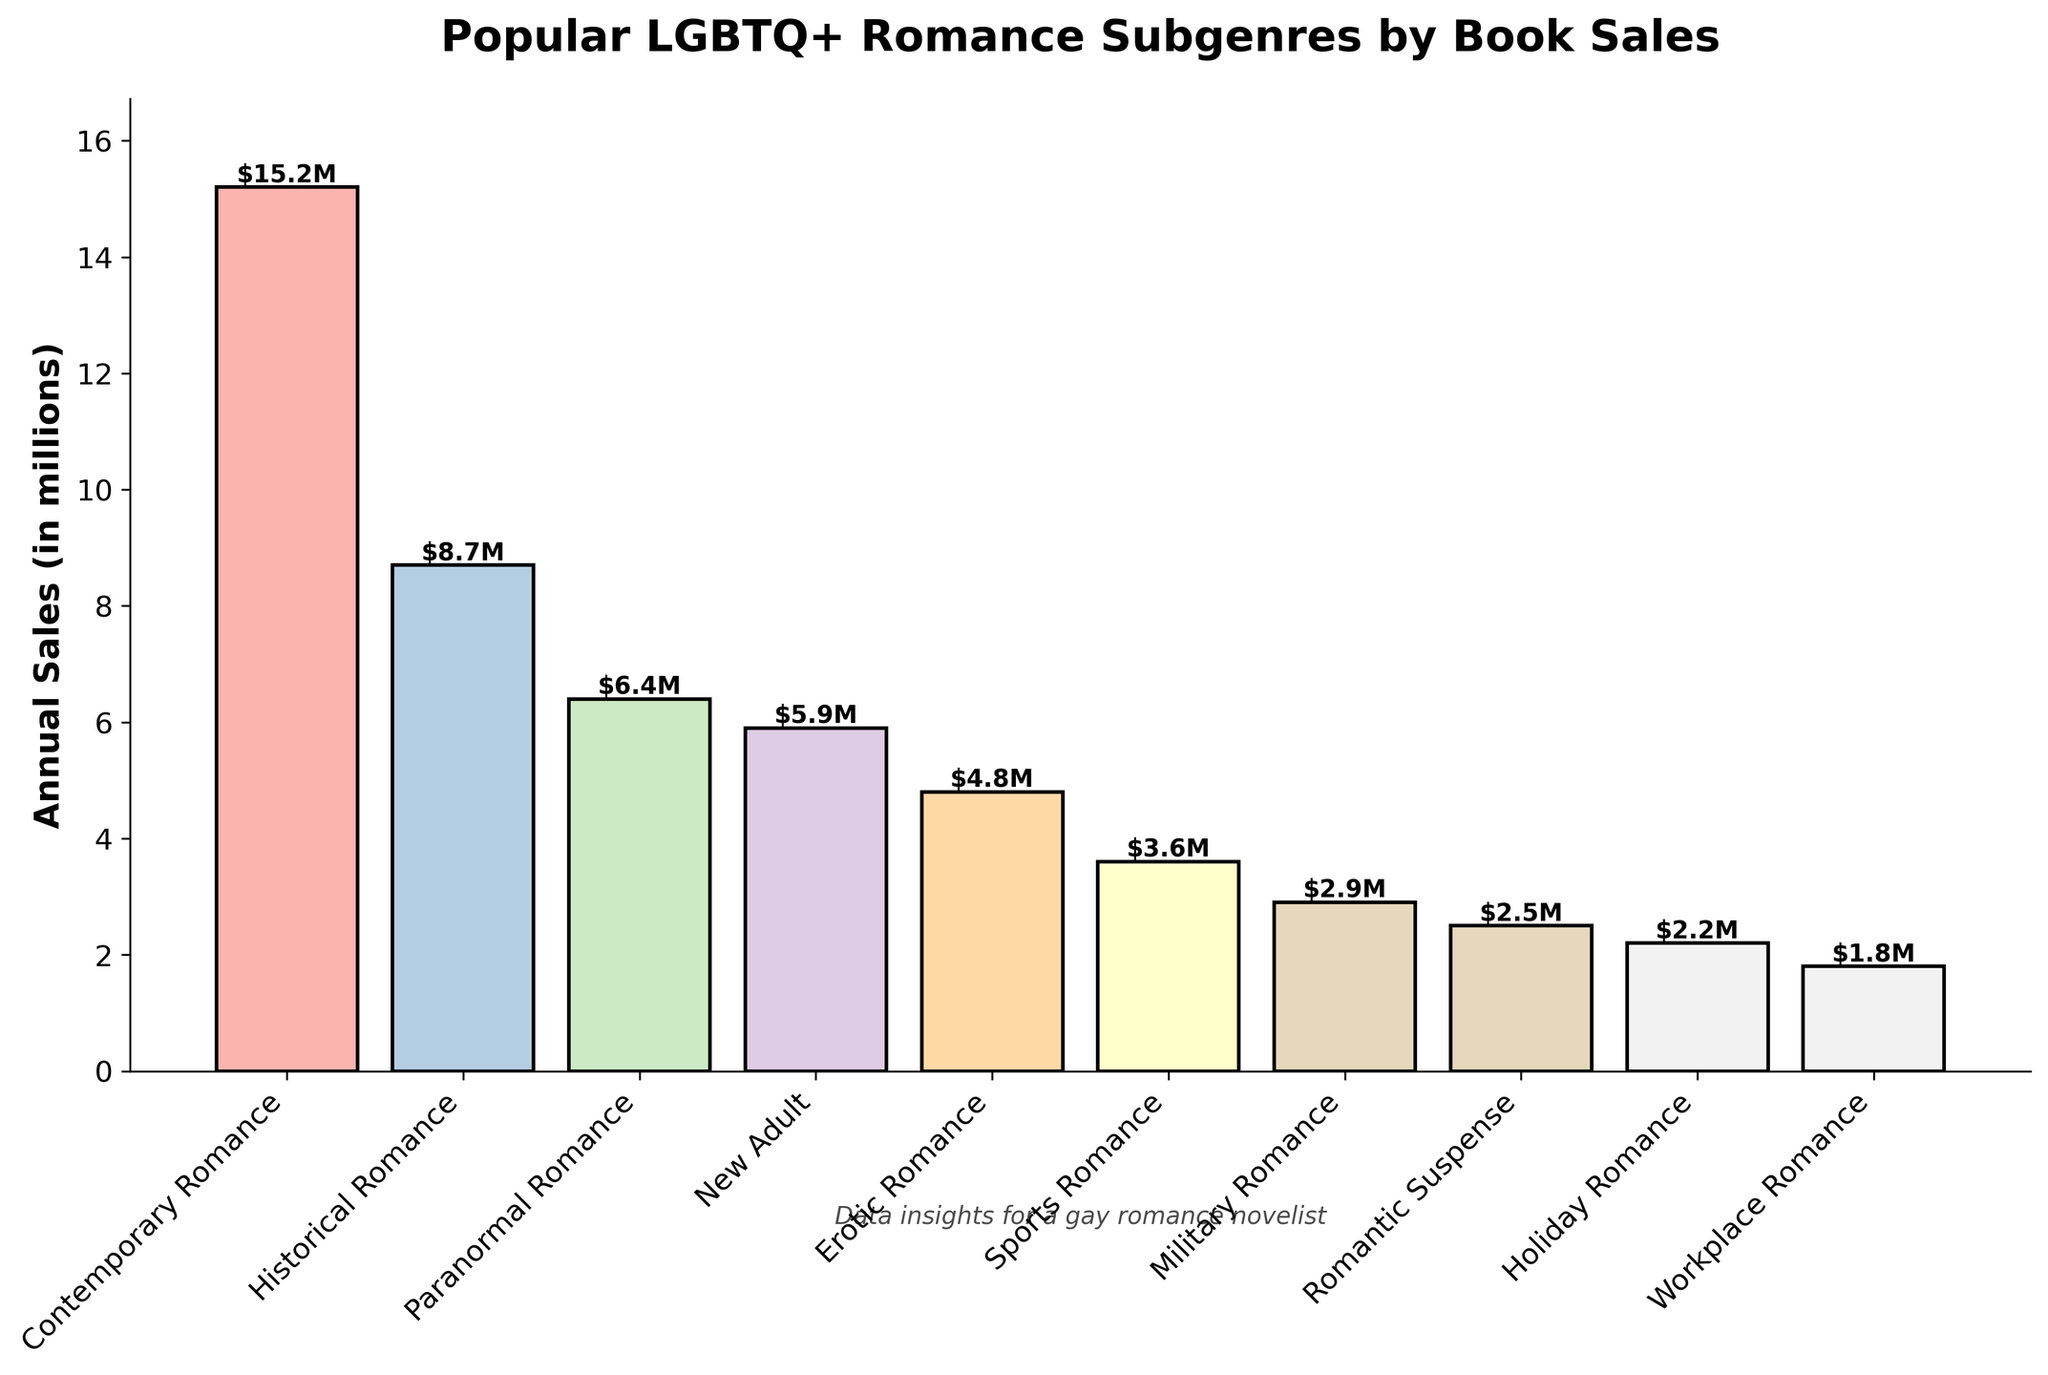What's the total annual sales for Contemporary Romance and Historical Romance? Add the sales figures for Contemporary Romance (15.2 million) and Historical Romance (8.7 million). The total is 15.2 + 8.7 = 23.9 million.
Answer: 23.9 million Which subgenre has the lowest annual sales? Look for the shortest bar in the plot. The shortest bar corresponds to Workplace Romance with annual sales of 1.8 million.
Answer: Workplace Romance What's the difference in annual sales between Paranormal Romance and Romantic Suspense? Subtract the sales of Romantic Suspense (2.5 million) from the sales of Paranormal Romance (6.4 million). The difference is 6.4 - 2.5 = 3.9 million.
Answer: 3.9 million Are the sales of Erotic Romance higher or lower than those of Sports Romance? Compare the heights of the bars for Erotic Romance and Sports Romance. Erotic Romance has higher sales (4.8 million) compared to Sports Romance (3.6 million).
Answer: Higher What's the average annual sales of the top three subgenres? Identify the top three subgenres: Contemporary Romance (15.2 million), Historical Romance (8.7 million), and Paranormal Romance (6.4 million). Calculate the average: (15.2 + 8.7 + 6.4) / 3 = 10.1 million.
Answer: 10.1 million Which subgenres have annual sales between 2 million and 5 million? Identify bars with heights within the 2 million to 5 million range: Erotic Romance (4.8 million), Sports Romance (3.6 million), Military Romance (2.9 million), and Romantic Suspense (2.5 million), and Holiday Romance (2.2 million).
Answer: Erotic Romance, Sports Romance, Military Romance, Romantic Suspense, and Holiday Romance By how much do the sales of Military Romance exceed those of Workplace Romance? Subtract the sales of Workplace Romance (1.8 million) from the sales of Military Romance (2.9 million). The difference is 2.9 - 1.8 = 1.1 million.
Answer: 1.1 million Which subgenre is just below Paranormal Romance in terms of annual sales? Look at the bar immediately shorter than Paranormal Romance (6.4 million). The next shortest bar belongs to New Adult with sales of 5.9 million.
Answer: New Adult 